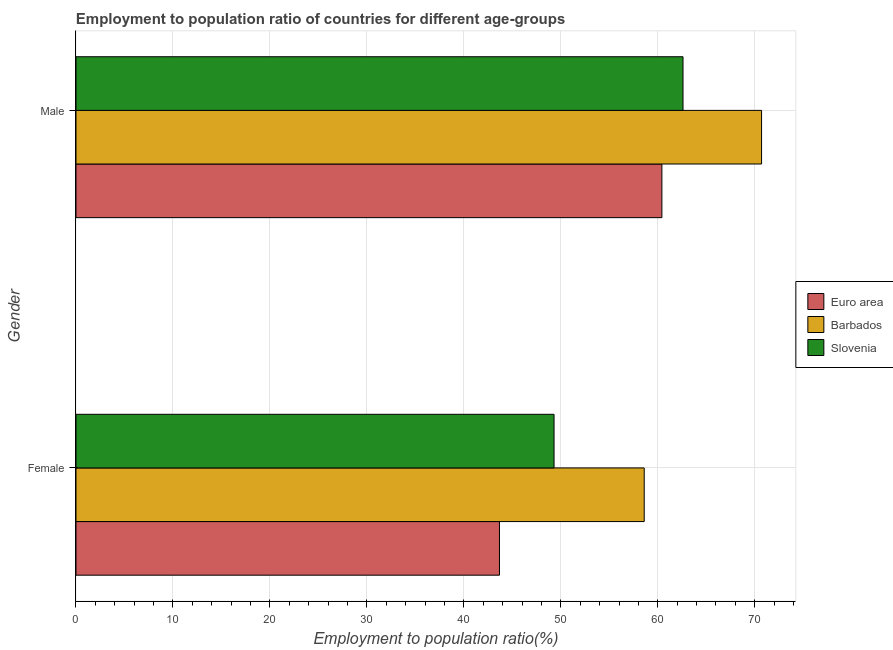How many different coloured bars are there?
Give a very brief answer. 3. How many groups of bars are there?
Keep it short and to the point. 2. Are the number of bars per tick equal to the number of legend labels?
Your response must be concise. Yes. How many bars are there on the 2nd tick from the bottom?
Ensure brevity in your answer.  3. What is the employment to population ratio(male) in Euro area?
Make the answer very short. 60.42. Across all countries, what is the maximum employment to population ratio(female)?
Give a very brief answer. 58.6. Across all countries, what is the minimum employment to population ratio(male)?
Your answer should be compact. 60.42. In which country was the employment to population ratio(male) maximum?
Provide a short and direct response. Barbados. What is the total employment to population ratio(female) in the graph?
Make the answer very short. 151.57. What is the difference between the employment to population ratio(female) in Barbados and that in Euro area?
Give a very brief answer. 14.93. What is the difference between the employment to population ratio(female) in Slovenia and the employment to population ratio(male) in Barbados?
Your response must be concise. -21.4. What is the average employment to population ratio(male) per country?
Provide a succinct answer. 64.57. What is the difference between the employment to population ratio(male) and employment to population ratio(female) in Euro area?
Give a very brief answer. 16.75. What is the ratio of the employment to population ratio(male) in Slovenia to that in Euro area?
Offer a terse response. 1.04. Is the employment to population ratio(male) in Euro area less than that in Barbados?
Offer a very short reply. Yes. What does the 2nd bar from the top in Female represents?
Provide a succinct answer. Barbados. How many countries are there in the graph?
Provide a short and direct response. 3. What is the difference between two consecutive major ticks on the X-axis?
Offer a terse response. 10. How are the legend labels stacked?
Offer a very short reply. Vertical. What is the title of the graph?
Make the answer very short. Employment to population ratio of countries for different age-groups. What is the Employment to population ratio(%) of Euro area in Female?
Make the answer very short. 43.67. What is the Employment to population ratio(%) in Barbados in Female?
Your answer should be compact. 58.6. What is the Employment to population ratio(%) of Slovenia in Female?
Keep it short and to the point. 49.3. What is the Employment to population ratio(%) of Euro area in Male?
Your answer should be very brief. 60.42. What is the Employment to population ratio(%) in Barbados in Male?
Offer a very short reply. 70.7. What is the Employment to population ratio(%) of Slovenia in Male?
Provide a short and direct response. 62.6. Across all Gender, what is the maximum Employment to population ratio(%) in Euro area?
Your response must be concise. 60.42. Across all Gender, what is the maximum Employment to population ratio(%) of Barbados?
Provide a short and direct response. 70.7. Across all Gender, what is the maximum Employment to population ratio(%) of Slovenia?
Offer a very short reply. 62.6. Across all Gender, what is the minimum Employment to population ratio(%) of Euro area?
Give a very brief answer. 43.67. Across all Gender, what is the minimum Employment to population ratio(%) in Barbados?
Your response must be concise. 58.6. Across all Gender, what is the minimum Employment to population ratio(%) of Slovenia?
Ensure brevity in your answer.  49.3. What is the total Employment to population ratio(%) of Euro area in the graph?
Give a very brief answer. 104.09. What is the total Employment to population ratio(%) in Barbados in the graph?
Provide a succinct answer. 129.3. What is the total Employment to population ratio(%) in Slovenia in the graph?
Keep it short and to the point. 111.9. What is the difference between the Employment to population ratio(%) in Euro area in Female and that in Male?
Offer a very short reply. -16.75. What is the difference between the Employment to population ratio(%) of Barbados in Female and that in Male?
Your answer should be compact. -12.1. What is the difference between the Employment to population ratio(%) in Slovenia in Female and that in Male?
Your answer should be very brief. -13.3. What is the difference between the Employment to population ratio(%) in Euro area in Female and the Employment to population ratio(%) in Barbados in Male?
Make the answer very short. -27.03. What is the difference between the Employment to population ratio(%) of Euro area in Female and the Employment to population ratio(%) of Slovenia in Male?
Your response must be concise. -18.93. What is the average Employment to population ratio(%) in Euro area per Gender?
Provide a short and direct response. 52.05. What is the average Employment to population ratio(%) in Barbados per Gender?
Your answer should be very brief. 64.65. What is the average Employment to population ratio(%) in Slovenia per Gender?
Offer a terse response. 55.95. What is the difference between the Employment to population ratio(%) of Euro area and Employment to population ratio(%) of Barbados in Female?
Your response must be concise. -14.93. What is the difference between the Employment to population ratio(%) of Euro area and Employment to population ratio(%) of Slovenia in Female?
Ensure brevity in your answer.  -5.63. What is the difference between the Employment to population ratio(%) in Euro area and Employment to population ratio(%) in Barbados in Male?
Ensure brevity in your answer.  -10.28. What is the difference between the Employment to population ratio(%) in Euro area and Employment to population ratio(%) in Slovenia in Male?
Your answer should be compact. -2.18. What is the difference between the Employment to population ratio(%) in Barbados and Employment to population ratio(%) in Slovenia in Male?
Your answer should be very brief. 8.1. What is the ratio of the Employment to population ratio(%) of Euro area in Female to that in Male?
Keep it short and to the point. 0.72. What is the ratio of the Employment to population ratio(%) of Barbados in Female to that in Male?
Keep it short and to the point. 0.83. What is the ratio of the Employment to population ratio(%) in Slovenia in Female to that in Male?
Make the answer very short. 0.79. What is the difference between the highest and the second highest Employment to population ratio(%) in Euro area?
Your answer should be compact. 16.75. What is the difference between the highest and the second highest Employment to population ratio(%) in Barbados?
Make the answer very short. 12.1. What is the difference between the highest and the second highest Employment to population ratio(%) in Slovenia?
Provide a succinct answer. 13.3. What is the difference between the highest and the lowest Employment to population ratio(%) in Euro area?
Give a very brief answer. 16.75. What is the difference between the highest and the lowest Employment to population ratio(%) in Barbados?
Make the answer very short. 12.1. What is the difference between the highest and the lowest Employment to population ratio(%) in Slovenia?
Provide a short and direct response. 13.3. 